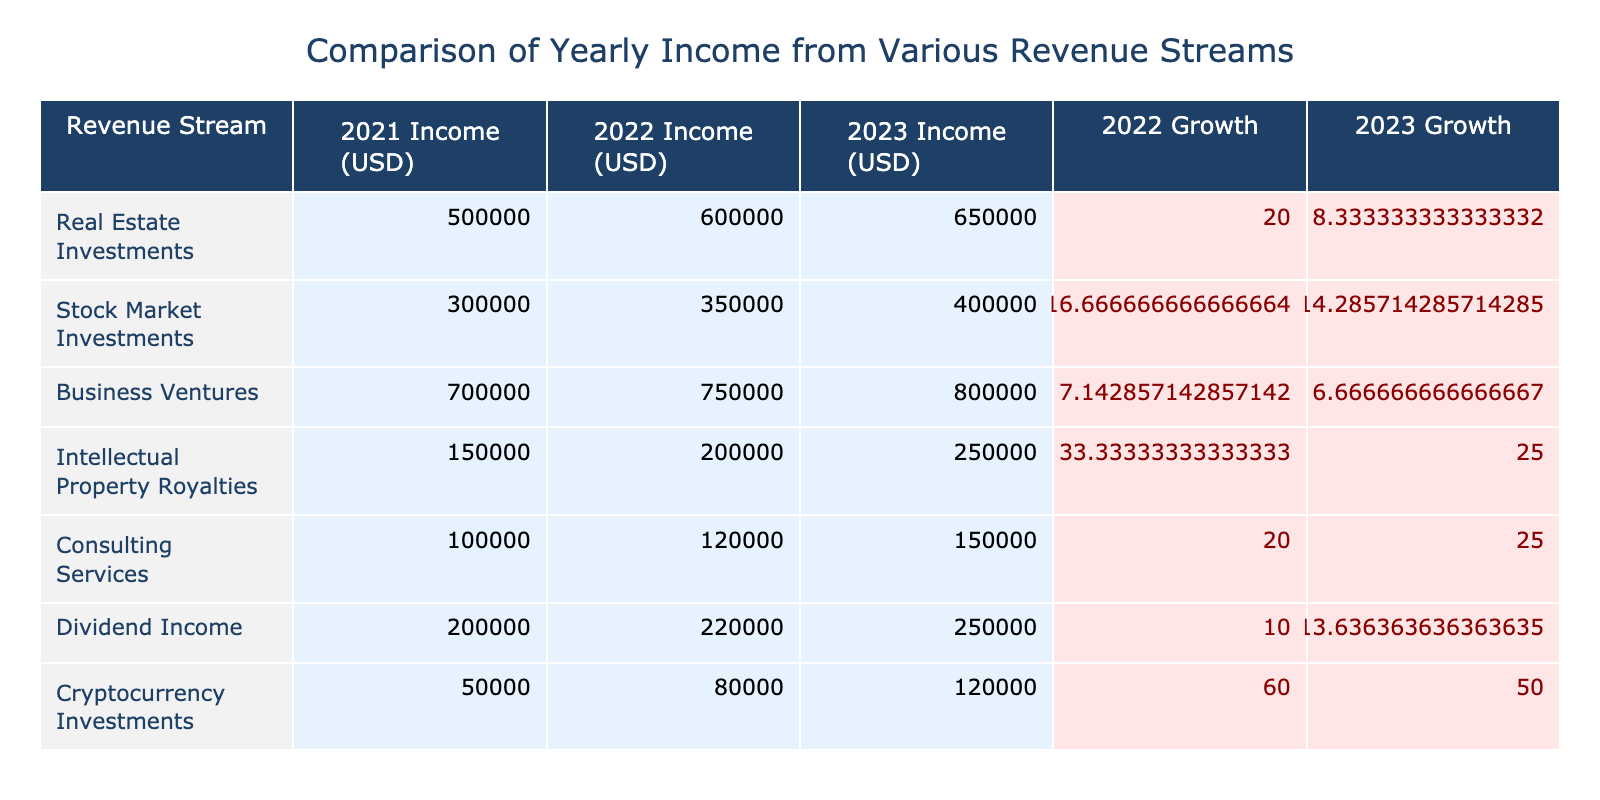What was the revenue from Stock Market Investments in 2023? In the table, the income from Stock Market Investments for 2023 is directly listed under that revenue stream in the corresponding year column. It shows an income of USD 400,000.
Answer: 400000 Which revenue stream had the highest income in 2022? By examining the income values for each revenue stream in 2022, Business Ventures has the highest income listed at USD 750,000, compared to others.
Answer: Business Ventures What is the total income from Real Estate Investments over the three years? To find the total income from Real Estate Investments, we sum the income values for 2021, 2022, and 2023: 500,000 + 600,000 + 650,000 = 1,750,000.
Answer: 1750000 Did Dividend Income increase every year? To determine this, we check the income values for Dividend Income across the years: it went from 200,000 in 2021 to 220,000 in 2022, then to 250,000 in 2023. Since all values increased year over year, the answer is yes.
Answer: Yes What is the average income from Intellectual Property Royalties across the three years? The income values for Intellectual Property Royalties are 150,000 for 2021, 200,000 for 2022, and 250,000 for 2023. To find the average, we sum these amounts (150,000 + 200,000 + 250,000 = 600,000) and then divide by the number of years (3), resulting in an average of 200,000.
Answer: 200000 Which revenue stream had the largest year-over-year growth percentage in 2023? We need to calculate the growth percentage for each revenue stream from 2022 to 2023. The calculations are as follows: Real Estate (8.33%), Stock Market (14.29%), Business Ventures (6.67%), Intellectual Property (25.00%), Consulting Services (25.00%), Dividend Income (13.64%), and Cryptocurrency Investments (50.00%). The highest growth percentage is from Cryptocurrency Investments.
Answer: Cryptocurrency Investments What was the combined income from Consulting Services and Cryptocurrency Investments in 2022? We look at the table for the 2022 income figures: Consulting Services provided 120,000 and Cryptocurrency Investments brought in 80,000. Adding these amounts together gives 120,000 + 80,000 = 200,000.
Answer: 200000 Was the income from Business Ventures higher than the combined income from Real Estate Investments and Stock Market Investments in 2021? The income from Business Ventures in 2021 is listed as 700,000. The combined income from Real Estate Investments (500,000) and Stock Market Investments (300,000) is 500,000 + 300,000 = 800,000. Since 700,000 is less than 800,000, the answer is no.
Answer: No 